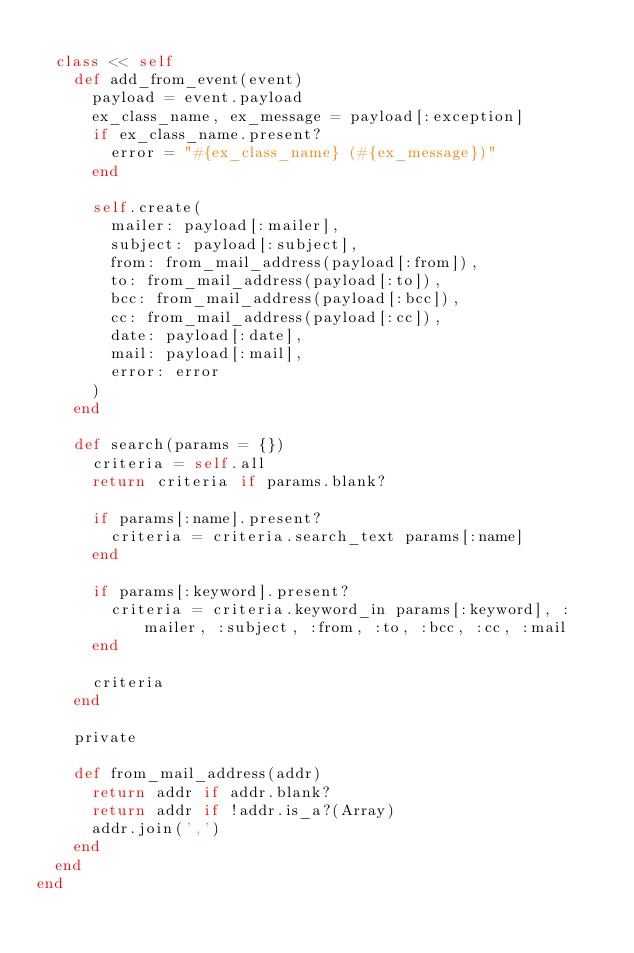<code> <loc_0><loc_0><loc_500><loc_500><_Ruby_>
  class << self
    def add_from_event(event)
      payload = event.payload
      ex_class_name, ex_message = payload[:exception]
      if ex_class_name.present?
        error = "#{ex_class_name} (#{ex_message})"
      end

      self.create(
        mailer: payload[:mailer],
        subject: payload[:subject],
        from: from_mail_address(payload[:from]),
        to: from_mail_address(payload[:to]),
        bcc: from_mail_address(payload[:bcc]),
        cc: from_mail_address(payload[:cc]),
        date: payload[:date],
        mail: payload[:mail],
        error: error
      )
    end

    def search(params = {})
      criteria = self.all
      return criteria if params.blank?

      if params[:name].present?
        criteria = criteria.search_text params[:name]
      end

      if params[:keyword].present?
        criteria = criteria.keyword_in params[:keyword], :mailer, :subject, :from, :to, :bcc, :cc, :mail
      end

      criteria
    end

    private

    def from_mail_address(addr)
      return addr if addr.blank?
      return addr if !addr.is_a?(Array)
      addr.join(',')
    end
  end
end
</code> 